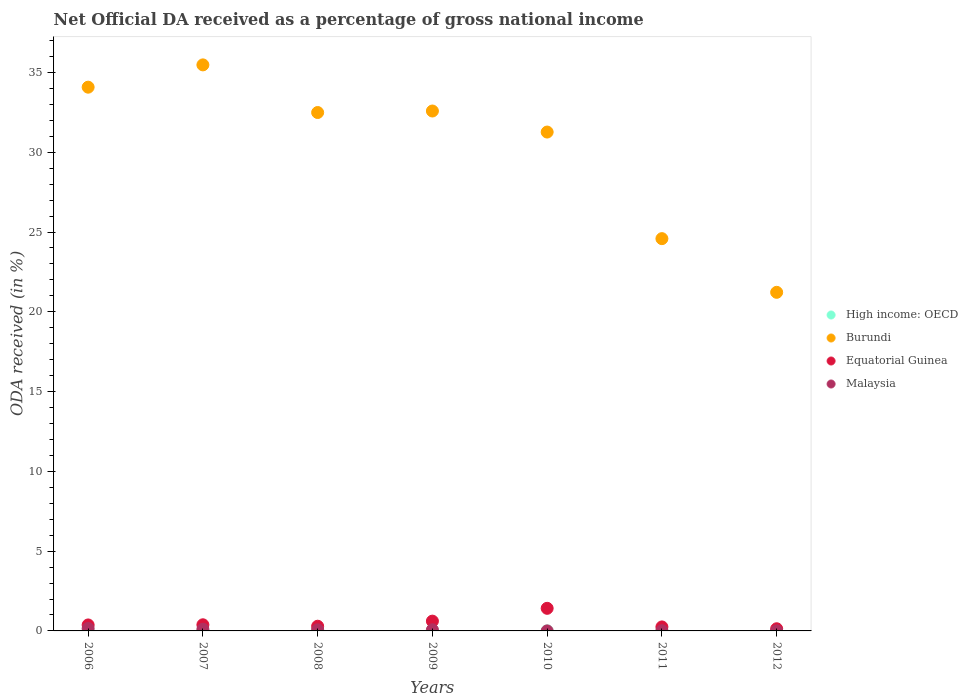What is the net official DA received in Malaysia in 2006?
Your answer should be compact. 0.15. Across all years, what is the maximum net official DA received in High income: OECD?
Provide a succinct answer. 0. Across all years, what is the minimum net official DA received in Malaysia?
Your answer should be very brief. 0. In which year was the net official DA received in Equatorial Guinea maximum?
Make the answer very short. 2010. What is the total net official DA received in Burundi in the graph?
Provide a short and direct response. 211.71. What is the difference between the net official DA received in Equatorial Guinea in 2008 and that in 2011?
Your answer should be very brief. 0.04. What is the difference between the net official DA received in High income: OECD in 2006 and the net official DA received in Malaysia in 2010?
Your response must be concise. -0. What is the average net official DA received in Equatorial Guinea per year?
Give a very brief answer. 0.5. In the year 2009, what is the difference between the net official DA received in Equatorial Guinea and net official DA received in Burundi?
Give a very brief answer. -31.97. What is the ratio of the net official DA received in Malaysia in 2009 to that in 2012?
Provide a short and direct response. 14.21. Is the difference between the net official DA received in Equatorial Guinea in 2007 and 2012 greater than the difference between the net official DA received in Burundi in 2007 and 2012?
Offer a very short reply. No. What is the difference between the highest and the second highest net official DA received in High income: OECD?
Make the answer very short. 0. What is the difference between the highest and the lowest net official DA received in High income: OECD?
Make the answer very short. 0. Is it the case that in every year, the sum of the net official DA received in Malaysia and net official DA received in Equatorial Guinea  is greater than the net official DA received in High income: OECD?
Give a very brief answer. Yes. How many years are there in the graph?
Offer a terse response. 7. What is the difference between two consecutive major ticks on the Y-axis?
Your answer should be very brief. 5. What is the title of the graph?
Provide a succinct answer. Net Official DA received as a percentage of gross national income. Does "Singapore" appear as one of the legend labels in the graph?
Keep it short and to the point. No. What is the label or title of the Y-axis?
Offer a very short reply. ODA received (in %). What is the ODA received (in %) of High income: OECD in 2006?
Offer a terse response. 0. What is the ODA received (in %) of Burundi in 2006?
Keep it short and to the point. 34.08. What is the ODA received (in %) in Equatorial Guinea in 2006?
Provide a short and direct response. 0.37. What is the ODA received (in %) of Malaysia in 2006?
Provide a short and direct response. 0.15. What is the ODA received (in %) in High income: OECD in 2007?
Your response must be concise. 0. What is the ODA received (in %) of Burundi in 2007?
Offer a very short reply. 35.48. What is the ODA received (in %) in Equatorial Guinea in 2007?
Provide a succinct answer. 0.38. What is the ODA received (in %) in Malaysia in 2007?
Your response must be concise. 0.11. What is the ODA received (in %) of High income: OECD in 2008?
Ensure brevity in your answer.  0. What is the ODA received (in %) of Burundi in 2008?
Give a very brief answer. 32.49. What is the ODA received (in %) of Equatorial Guinea in 2008?
Give a very brief answer. 0.29. What is the ODA received (in %) of Malaysia in 2008?
Keep it short and to the point. 0.07. What is the ODA received (in %) of High income: OECD in 2009?
Offer a very short reply. 0. What is the ODA received (in %) of Burundi in 2009?
Offer a terse response. 32.59. What is the ODA received (in %) of Equatorial Guinea in 2009?
Your answer should be very brief. 0.61. What is the ODA received (in %) of Malaysia in 2009?
Keep it short and to the point. 0.07. What is the ODA received (in %) in High income: OECD in 2010?
Provide a succinct answer. 0. What is the ODA received (in %) of Burundi in 2010?
Keep it short and to the point. 31.27. What is the ODA received (in %) in Equatorial Guinea in 2010?
Your response must be concise. 1.42. What is the ODA received (in %) of Malaysia in 2010?
Your response must be concise. 0. What is the ODA received (in %) in High income: OECD in 2011?
Offer a very short reply. 0. What is the ODA received (in %) of Burundi in 2011?
Offer a very short reply. 24.59. What is the ODA received (in %) in Equatorial Guinea in 2011?
Your response must be concise. 0.25. What is the ODA received (in %) in Malaysia in 2011?
Provide a short and direct response. 0.01. What is the ODA received (in %) of High income: OECD in 2012?
Keep it short and to the point. 0. What is the ODA received (in %) of Burundi in 2012?
Your answer should be compact. 21.22. What is the ODA received (in %) of Equatorial Guinea in 2012?
Provide a succinct answer. 0.14. What is the ODA received (in %) in Malaysia in 2012?
Provide a short and direct response. 0.01. Across all years, what is the maximum ODA received (in %) in High income: OECD?
Make the answer very short. 0. Across all years, what is the maximum ODA received (in %) in Burundi?
Give a very brief answer. 35.48. Across all years, what is the maximum ODA received (in %) of Equatorial Guinea?
Make the answer very short. 1.42. Across all years, what is the maximum ODA received (in %) of Malaysia?
Offer a terse response. 0.15. Across all years, what is the minimum ODA received (in %) of High income: OECD?
Provide a short and direct response. 0. Across all years, what is the minimum ODA received (in %) of Burundi?
Keep it short and to the point. 21.22. Across all years, what is the minimum ODA received (in %) of Equatorial Guinea?
Keep it short and to the point. 0.14. Across all years, what is the minimum ODA received (in %) of Malaysia?
Ensure brevity in your answer.  0. What is the total ODA received (in %) of High income: OECD in the graph?
Offer a very short reply. 0. What is the total ODA received (in %) of Burundi in the graph?
Your answer should be compact. 211.71. What is the total ODA received (in %) of Equatorial Guinea in the graph?
Give a very brief answer. 3.47. What is the total ODA received (in %) of Malaysia in the graph?
Provide a succinct answer. 0.41. What is the difference between the ODA received (in %) in High income: OECD in 2006 and that in 2007?
Ensure brevity in your answer.  0. What is the difference between the ODA received (in %) in Burundi in 2006 and that in 2007?
Your answer should be very brief. -1.4. What is the difference between the ODA received (in %) of Equatorial Guinea in 2006 and that in 2007?
Offer a terse response. -0.01. What is the difference between the ODA received (in %) of Malaysia in 2006 and that in 2007?
Offer a terse response. 0.05. What is the difference between the ODA received (in %) of High income: OECD in 2006 and that in 2008?
Your answer should be compact. 0. What is the difference between the ODA received (in %) in Burundi in 2006 and that in 2008?
Your answer should be very brief. 1.59. What is the difference between the ODA received (in %) of Equatorial Guinea in 2006 and that in 2008?
Offer a very short reply. 0.08. What is the difference between the ODA received (in %) in Malaysia in 2006 and that in 2008?
Offer a very short reply. 0.08. What is the difference between the ODA received (in %) of Burundi in 2006 and that in 2009?
Ensure brevity in your answer.  1.49. What is the difference between the ODA received (in %) of Equatorial Guinea in 2006 and that in 2009?
Ensure brevity in your answer.  -0.24. What is the difference between the ODA received (in %) in Malaysia in 2006 and that in 2009?
Give a very brief answer. 0.08. What is the difference between the ODA received (in %) of High income: OECD in 2006 and that in 2010?
Provide a succinct answer. -0. What is the difference between the ODA received (in %) in Burundi in 2006 and that in 2010?
Your answer should be compact. 2.81. What is the difference between the ODA received (in %) of Equatorial Guinea in 2006 and that in 2010?
Give a very brief answer. -1.04. What is the difference between the ODA received (in %) of Malaysia in 2006 and that in 2010?
Provide a succinct answer. 0.15. What is the difference between the ODA received (in %) of High income: OECD in 2006 and that in 2011?
Ensure brevity in your answer.  -0. What is the difference between the ODA received (in %) in Burundi in 2006 and that in 2011?
Give a very brief answer. 9.49. What is the difference between the ODA received (in %) of Equatorial Guinea in 2006 and that in 2011?
Offer a terse response. 0.12. What is the difference between the ODA received (in %) in Malaysia in 2006 and that in 2011?
Keep it short and to the point. 0.14. What is the difference between the ODA received (in %) in Burundi in 2006 and that in 2012?
Provide a short and direct response. 12.86. What is the difference between the ODA received (in %) of Equatorial Guinea in 2006 and that in 2012?
Provide a succinct answer. 0.24. What is the difference between the ODA received (in %) of Malaysia in 2006 and that in 2012?
Make the answer very short. 0.15. What is the difference between the ODA received (in %) in Burundi in 2007 and that in 2008?
Offer a very short reply. 2.99. What is the difference between the ODA received (in %) in Equatorial Guinea in 2007 and that in 2008?
Make the answer very short. 0.09. What is the difference between the ODA received (in %) of Malaysia in 2007 and that in 2008?
Ensure brevity in your answer.  0.04. What is the difference between the ODA received (in %) in High income: OECD in 2007 and that in 2009?
Your response must be concise. 0. What is the difference between the ODA received (in %) of Burundi in 2007 and that in 2009?
Your response must be concise. 2.89. What is the difference between the ODA received (in %) in Equatorial Guinea in 2007 and that in 2009?
Make the answer very short. -0.23. What is the difference between the ODA received (in %) of Malaysia in 2007 and that in 2009?
Offer a very short reply. 0.03. What is the difference between the ODA received (in %) of High income: OECD in 2007 and that in 2010?
Offer a terse response. -0. What is the difference between the ODA received (in %) in Burundi in 2007 and that in 2010?
Your response must be concise. 4.21. What is the difference between the ODA received (in %) of Equatorial Guinea in 2007 and that in 2010?
Keep it short and to the point. -1.03. What is the difference between the ODA received (in %) of Malaysia in 2007 and that in 2010?
Provide a short and direct response. 0.1. What is the difference between the ODA received (in %) in High income: OECD in 2007 and that in 2011?
Ensure brevity in your answer.  -0. What is the difference between the ODA received (in %) of Burundi in 2007 and that in 2011?
Offer a very short reply. 10.89. What is the difference between the ODA received (in %) in Equatorial Guinea in 2007 and that in 2011?
Offer a very short reply. 0.13. What is the difference between the ODA received (in %) in Malaysia in 2007 and that in 2011?
Your answer should be very brief. 0.09. What is the difference between the ODA received (in %) of High income: OECD in 2007 and that in 2012?
Your response must be concise. -0. What is the difference between the ODA received (in %) in Burundi in 2007 and that in 2012?
Your answer should be very brief. 14.26. What is the difference between the ODA received (in %) of Equatorial Guinea in 2007 and that in 2012?
Your response must be concise. 0.25. What is the difference between the ODA received (in %) of Malaysia in 2007 and that in 2012?
Provide a succinct answer. 0.1. What is the difference between the ODA received (in %) of High income: OECD in 2008 and that in 2009?
Your answer should be compact. 0. What is the difference between the ODA received (in %) in Burundi in 2008 and that in 2009?
Offer a very short reply. -0.09. What is the difference between the ODA received (in %) in Equatorial Guinea in 2008 and that in 2009?
Give a very brief answer. -0.32. What is the difference between the ODA received (in %) of Malaysia in 2008 and that in 2009?
Provide a short and direct response. -0. What is the difference between the ODA received (in %) of High income: OECD in 2008 and that in 2010?
Your answer should be very brief. -0. What is the difference between the ODA received (in %) in Burundi in 2008 and that in 2010?
Keep it short and to the point. 1.22. What is the difference between the ODA received (in %) of Equatorial Guinea in 2008 and that in 2010?
Provide a short and direct response. -1.12. What is the difference between the ODA received (in %) in Malaysia in 2008 and that in 2010?
Provide a short and direct response. 0.07. What is the difference between the ODA received (in %) of High income: OECD in 2008 and that in 2011?
Offer a very short reply. -0. What is the difference between the ODA received (in %) in Burundi in 2008 and that in 2011?
Make the answer very short. 7.91. What is the difference between the ODA received (in %) of Equatorial Guinea in 2008 and that in 2011?
Offer a very short reply. 0.04. What is the difference between the ODA received (in %) in Malaysia in 2008 and that in 2011?
Make the answer very short. 0.06. What is the difference between the ODA received (in %) in Burundi in 2008 and that in 2012?
Provide a short and direct response. 11.27. What is the difference between the ODA received (in %) in Equatorial Guinea in 2008 and that in 2012?
Ensure brevity in your answer.  0.16. What is the difference between the ODA received (in %) in Malaysia in 2008 and that in 2012?
Offer a very short reply. 0.06. What is the difference between the ODA received (in %) of High income: OECD in 2009 and that in 2010?
Ensure brevity in your answer.  -0. What is the difference between the ODA received (in %) of Burundi in 2009 and that in 2010?
Make the answer very short. 1.32. What is the difference between the ODA received (in %) in Equatorial Guinea in 2009 and that in 2010?
Make the answer very short. -0.8. What is the difference between the ODA received (in %) in Malaysia in 2009 and that in 2010?
Your answer should be very brief. 0.07. What is the difference between the ODA received (in %) of High income: OECD in 2009 and that in 2011?
Your response must be concise. -0. What is the difference between the ODA received (in %) of Burundi in 2009 and that in 2011?
Give a very brief answer. 8. What is the difference between the ODA received (in %) of Equatorial Guinea in 2009 and that in 2011?
Your answer should be compact. 0.36. What is the difference between the ODA received (in %) of Malaysia in 2009 and that in 2011?
Make the answer very short. 0.06. What is the difference between the ODA received (in %) in High income: OECD in 2009 and that in 2012?
Provide a succinct answer. -0. What is the difference between the ODA received (in %) of Burundi in 2009 and that in 2012?
Your answer should be very brief. 11.36. What is the difference between the ODA received (in %) in Equatorial Guinea in 2009 and that in 2012?
Your answer should be compact. 0.48. What is the difference between the ODA received (in %) in Malaysia in 2009 and that in 2012?
Your answer should be very brief. 0.07. What is the difference between the ODA received (in %) of High income: OECD in 2010 and that in 2011?
Provide a short and direct response. 0. What is the difference between the ODA received (in %) of Burundi in 2010 and that in 2011?
Offer a terse response. 6.68. What is the difference between the ODA received (in %) in Equatorial Guinea in 2010 and that in 2011?
Offer a terse response. 1.17. What is the difference between the ODA received (in %) of Malaysia in 2010 and that in 2011?
Offer a terse response. -0.01. What is the difference between the ODA received (in %) in High income: OECD in 2010 and that in 2012?
Your response must be concise. 0. What is the difference between the ODA received (in %) of Burundi in 2010 and that in 2012?
Ensure brevity in your answer.  10.04. What is the difference between the ODA received (in %) in Equatorial Guinea in 2010 and that in 2012?
Offer a terse response. 1.28. What is the difference between the ODA received (in %) of Malaysia in 2010 and that in 2012?
Your answer should be very brief. -0. What is the difference between the ODA received (in %) of Burundi in 2011 and that in 2012?
Your answer should be very brief. 3.36. What is the difference between the ODA received (in %) in Equatorial Guinea in 2011 and that in 2012?
Keep it short and to the point. 0.11. What is the difference between the ODA received (in %) in Malaysia in 2011 and that in 2012?
Provide a short and direct response. 0.01. What is the difference between the ODA received (in %) of High income: OECD in 2006 and the ODA received (in %) of Burundi in 2007?
Keep it short and to the point. -35.48. What is the difference between the ODA received (in %) of High income: OECD in 2006 and the ODA received (in %) of Equatorial Guinea in 2007?
Ensure brevity in your answer.  -0.38. What is the difference between the ODA received (in %) of High income: OECD in 2006 and the ODA received (in %) of Malaysia in 2007?
Your answer should be compact. -0.11. What is the difference between the ODA received (in %) in Burundi in 2006 and the ODA received (in %) in Equatorial Guinea in 2007?
Offer a terse response. 33.69. What is the difference between the ODA received (in %) of Burundi in 2006 and the ODA received (in %) of Malaysia in 2007?
Your answer should be very brief. 33.97. What is the difference between the ODA received (in %) in Equatorial Guinea in 2006 and the ODA received (in %) in Malaysia in 2007?
Your response must be concise. 0.27. What is the difference between the ODA received (in %) of High income: OECD in 2006 and the ODA received (in %) of Burundi in 2008?
Offer a very short reply. -32.49. What is the difference between the ODA received (in %) in High income: OECD in 2006 and the ODA received (in %) in Equatorial Guinea in 2008?
Ensure brevity in your answer.  -0.29. What is the difference between the ODA received (in %) of High income: OECD in 2006 and the ODA received (in %) of Malaysia in 2008?
Give a very brief answer. -0.07. What is the difference between the ODA received (in %) of Burundi in 2006 and the ODA received (in %) of Equatorial Guinea in 2008?
Ensure brevity in your answer.  33.79. What is the difference between the ODA received (in %) in Burundi in 2006 and the ODA received (in %) in Malaysia in 2008?
Ensure brevity in your answer.  34.01. What is the difference between the ODA received (in %) of Equatorial Guinea in 2006 and the ODA received (in %) of Malaysia in 2008?
Provide a short and direct response. 0.31. What is the difference between the ODA received (in %) of High income: OECD in 2006 and the ODA received (in %) of Burundi in 2009?
Your response must be concise. -32.58. What is the difference between the ODA received (in %) of High income: OECD in 2006 and the ODA received (in %) of Equatorial Guinea in 2009?
Your answer should be very brief. -0.61. What is the difference between the ODA received (in %) of High income: OECD in 2006 and the ODA received (in %) of Malaysia in 2009?
Ensure brevity in your answer.  -0.07. What is the difference between the ODA received (in %) of Burundi in 2006 and the ODA received (in %) of Equatorial Guinea in 2009?
Your response must be concise. 33.47. What is the difference between the ODA received (in %) in Burundi in 2006 and the ODA received (in %) in Malaysia in 2009?
Provide a succinct answer. 34.01. What is the difference between the ODA received (in %) in Equatorial Guinea in 2006 and the ODA received (in %) in Malaysia in 2009?
Give a very brief answer. 0.3. What is the difference between the ODA received (in %) in High income: OECD in 2006 and the ODA received (in %) in Burundi in 2010?
Your response must be concise. -31.27. What is the difference between the ODA received (in %) in High income: OECD in 2006 and the ODA received (in %) in Equatorial Guinea in 2010?
Make the answer very short. -1.42. What is the difference between the ODA received (in %) in High income: OECD in 2006 and the ODA received (in %) in Malaysia in 2010?
Your answer should be compact. -0. What is the difference between the ODA received (in %) in Burundi in 2006 and the ODA received (in %) in Equatorial Guinea in 2010?
Offer a terse response. 32.66. What is the difference between the ODA received (in %) in Burundi in 2006 and the ODA received (in %) in Malaysia in 2010?
Your answer should be very brief. 34.08. What is the difference between the ODA received (in %) of Equatorial Guinea in 2006 and the ODA received (in %) of Malaysia in 2010?
Your response must be concise. 0.37. What is the difference between the ODA received (in %) of High income: OECD in 2006 and the ODA received (in %) of Burundi in 2011?
Provide a succinct answer. -24.59. What is the difference between the ODA received (in %) of High income: OECD in 2006 and the ODA received (in %) of Equatorial Guinea in 2011?
Ensure brevity in your answer.  -0.25. What is the difference between the ODA received (in %) in High income: OECD in 2006 and the ODA received (in %) in Malaysia in 2011?
Ensure brevity in your answer.  -0.01. What is the difference between the ODA received (in %) of Burundi in 2006 and the ODA received (in %) of Equatorial Guinea in 2011?
Offer a terse response. 33.83. What is the difference between the ODA received (in %) in Burundi in 2006 and the ODA received (in %) in Malaysia in 2011?
Your response must be concise. 34.07. What is the difference between the ODA received (in %) of Equatorial Guinea in 2006 and the ODA received (in %) of Malaysia in 2011?
Your response must be concise. 0.36. What is the difference between the ODA received (in %) of High income: OECD in 2006 and the ODA received (in %) of Burundi in 2012?
Keep it short and to the point. -21.22. What is the difference between the ODA received (in %) in High income: OECD in 2006 and the ODA received (in %) in Equatorial Guinea in 2012?
Ensure brevity in your answer.  -0.14. What is the difference between the ODA received (in %) of High income: OECD in 2006 and the ODA received (in %) of Malaysia in 2012?
Keep it short and to the point. -0. What is the difference between the ODA received (in %) of Burundi in 2006 and the ODA received (in %) of Equatorial Guinea in 2012?
Your response must be concise. 33.94. What is the difference between the ODA received (in %) of Burundi in 2006 and the ODA received (in %) of Malaysia in 2012?
Keep it short and to the point. 34.07. What is the difference between the ODA received (in %) in Equatorial Guinea in 2006 and the ODA received (in %) in Malaysia in 2012?
Offer a very short reply. 0.37. What is the difference between the ODA received (in %) in High income: OECD in 2007 and the ODA received (in %) in Burundi in 2008?
Ensure brevity in your answer.  -32.49. What is the difference between the ODA received (in %) of High income: OECD in 2007 and the ODA received (in %) of Equatorial Guinea in 2008?
Provide a short and direct response. -0.29. What is the difference between the ODA received (in %) of High income: OECD in 2007 and the ODA received (in %) of Malaysia in 2008?
Provide a succinct answer. -0.07. What is the difference between the ODA received (in %) of Burundi in 2007 and the ODA received (in %) of Equatorial Guinea in 2008?
Provide a short and direct response. 35.18. What is the difference between the ODA received (in %) in Burundi in 2007 and the ODA received (in %) in Malaysia in 2008?
Offer a terse response. 35.41. What is the difference between the ODA received (in %) of Equatorial Guinea in 2007 and the ODA received (in %) of Malaysia in 2008?
Your answer should be very brief. 0.32. What is the difference between the ODA received (in %) in High income: OECD in 2007 and the ODA received (in %) in Burundi in 2009?
Provide a succinct answer. -32.58. What is the difference between the ODA received (in %) of High income: OECD in 2007 and the ODA received (in %) of Equatorial Guinea in 2009?
Offer a terse response. -0.61. What is the difference between the ODA received (in %) in High income: OECD in 2007 and the ODA received (in %) in Malaysia in 2009?
Give a very brief answer. -0.07. What is the difference between the ODA received (in %) of Burundi in 2007 and the ODA received (in %) of Equatorial Guinea in 2009?
Ensure brevity in your answer.  34.86. What is the difference between the ODA received (in %) in Burundi in 2007 and the ODA received (in %) in Malaysia in 2009?
Offer a very short reply. 35.4. What is the difference between the ODA received (in %) of Equatorial Guinea in 2007 and the ODA received (in %) of Malaysia in 2009?
Your answer should be compact. 0.31. What is the difference between the ODA received (in %) of High income: OECD in 2007 and the ODA received (in %) of Burundi in 2010?
Make the answer very short. -31.27. What is the difference between the ODA received (in %) of High income: OECD in 2007 and the ODA received (in %) of Equatorial Guinea in 2010?
Keep it short and to the point. -1.42. What is the difference between the ODA received (in %) in High income: OECD in 2007 and the ODA received (in %) in Malaysia in 2010?
Offer a very short reply. -0. What is the difference between the ODA received (in %) in Burundi in 2007 and the ODA received (in %) in Equatorial Guinea in 2010?
Provide a short and direct response. 34.06. What is the difference between the ODA received (in %) in Burundi in 2007 and the ODA received (in %) in Malaysia in 2010?
Your response must be concise. 35.48. What is the difference between the ODA received (in %) in Equatorial Guinea in 2007 and the ODA received (in %) in Malaysia in 2010?
Offer a very short reply. 0.38. What is the difference between the ODA received (in %) of High income: OECD in 2007 and the ODA received (in %) of Burundi in 2011?
Provide a short and direct response. -24.59. What is the difference between the ODA received (in %) in High income: OECD in 2007 and the ODA received (in %) in Equatorial Guinea in 2011?
Keep it short and to the point. -0.25. What is the difference between the ODA received (in %) of High income: OECD in 2007 and the ODA received (in %) of Malaysia in 2011?
Provide a succinct answer. -0.01. What is the difference between the ODA received (in %) in Burundi in 2007 and the ODA received (in %) in Equatorial Guinea in 2011?
Offer a very short reply. 35.23. What is the difference between the ODA received (in %) in Burundi in 2007 and the ODA received (in %) in Malaysia in 2011?
Offer a very short reply. 35.47. What is the difference between the ODA received (in %) in Equatorial Guinea in 2007 and the ODA received (in %) in Malaysia in 2011?
Provide a short and direct response. 0.37. What is the difference between the ODA received (in %) of High income: OECD in 2007 and the ODA received (in %) of Burundi in 2012?
Ensure brevity in your answer.  -21.22. What is the difference between the ODA received (in %) of High income: OECD in 2007 and the ODA received (in %) of Equatorial Guinea in 2012?
Offer a very short reply. -0.14. What is the difference between the ODA received (in %) of High income: OECD in 2007 and the ODA received (in %) of Malaysia in 2012?
Make the answer very short. -0. What is the difference between the ODA received (in %) of Burundi in 2007 and the ODA received (in %) of Equatorial Guinea in 2012?
Your answer should be very brief. 35.34. What is the difference between the ODA received (in %) of Burundi in 2007 and the ODA received (in %) of Malaysia in 2012?
Your answer should be compact. 35.47. What is the difference between the ODA received (in %) of Equatorial Guinea in 2007 and the ODA received (in %) of Malaysia in 2012?
Your answer should be compact. 0.38. What is the difference between the ODA received (in %) in High income: OECD in 2008 and the ODA received (in %) in Burundi in 2009?
Your response must be concise. -32.58. What is the difference between the ODA received (in %) in High income: OECD in 2008 and the ODA received (in %) in Equatorial Guinea in 2009?
Offer a very short reply. -0.61. What is the difference between the ODA received (in %) in High income: OECD in 2008 and the ODA received (in %) in Malaysia in 2009?
Give a very brief answer. -0.07. What is the difference between the ODA received (in %) of Burundi in 2008 and the ODA received (in %) of Equatorial Guinea in 2009?
Keep it short and to the point. 31.88. What is the difference between the ODA received (in %) in Burundi in 2008 and the ODA received (in %) in Malaysia in 2009?
Provide a short and direct response. 32.42. What is the difference between the ODA received (in %) in Equatorial Guinea in 2008 and the ODA received (in %) in Malaysia in 2009?
Give a very brief answer. 0.22. What is the difference between the ODA received (in %) in High income: OECD in 2008 and the ODA received (in %) in Burundi in 2010?
Provide a succinct answer. -31.27. What is the difference between the ODA received (in %) in High income: OECD in 2008 and the ODA received (in %) in Equatorial Guinea in 2010?
Give a very brief answer. -1.42. What is the difference between the ODA received (in %) in High income: OECD in 2008 and the ODA received (in %) in Malaysia in 2010?
Your response must be concise. -0. What is the difference between the ODA received (in %) in Burundi in 2008 and the ODA received (in %) in Equatorial Guinea in 2010?
Offer a terse response. 31.07. What is the difference between the ODA received (in %) of Burundi in 2008 and the ODA received (in %) of Malaysia in 2010?
Offer a terse response. 32.49. What is the difference between the ODA received (in %) of Equatorial Guinea in 2008 and the ODA received (in %) of Malaysia in 2010?
Your answer should be compact. 0.29. What is the difference between the ODA received (in %) in High income: OECD in 2008 and the ODA received (in %) in Burundi in 2011?
Your response must be concise. -24.59. What is the difference between the ODA received (in %) of High income: OECD in 2008 and the ODA received (in %) of Equatorial Guinea in 2011?
Provide a short and direct response. -0.25. What is the difference between the ODA received (in %) in High income: OECD in 2008 and the ODA received (in %) in Malaysia in 2011?
Offer a very short reply. -0.01. What is the difference between the ODA received (in %) in Burundi in 2008 and the ODA received (in %) in Equatorial Guinea in 2011?
Keep it short and to the point. 32.24. What is the difference between the ODA received (in %) of Burundi in 2008 and the ODA received (in %) of Malaysia in 2011?
Ensure brevity in your answer.  32.48. What is the difference between the ODA received (in %) in Equatorial Guinea in 2008 and the ODA received (in %) in Malaysia in 2011?
Offer a terse response. 0.28. What is the difference between the ODA received (in %) in High income: OECD in 2008 and the ODA received (in %) in Burundi in 2012?
Offer a terse response. -21.22. What is the difference between the ODA received (in %) in High income: OECD in 2008 and the ODA received (in %) in Equatorial Guinea in 2012?
Provide a short and direct response. -0.14. What is the difference between the ODA received (in %) in High income: OECD in 2008 and the ODA received (in %) in Malaysia in 2012?
Offer a terse response. -0. What is the difference between the ODA received (in %) in Burundi in 2008 and the ODA received (in %) in Equatorial Guinea in 2012?
Provide a succinct answer. 32.36. What is the difference between the ODA received (in %) in Burundi in 2008 and the ODA received (in %) in Malaysia in 2012?
Give a very brief answer. 32.49. What is the difference between the ODA received (in %) in Equatorial Guinea in 2008 and the ODA received (in %) in Malaysia in 2012?
Make the answer very short. 0.29. What is the difference between the ODA received (in %) in High income: OECD in 2009 and the ODA received (in %) in Burundi in 2010?
Ensure brevity in your answer.  -31.27. What is the difference between the ODA received (in %) of High income: OECD in 2009 and the ODA received (in %) of Equatorial Guinea in 2010?
Offer a very short reply. -1.42. What is the difference between the ODA received (in %) in High income: OECD in 2009 and the ODA received (in %) in Malaysia in 2010?
Your answer should be compact. -0. What is the difference between the ODA received (in %) in Burundi in 2009 and the ODA received (in %) in Equatorial Guinea in 2010?
Ensure brevity in your answer.  31.17. What is the difference between the ODA received (in %) in Burundi in 2009 and the ODA received (in %) in Malaysia in 2010?
Give a very brief answer. 32.58. What is the difference between the ODA received (in %) of Equatorial Guinea in 2009 and the ODA received (in %) of Malaysia in 2010?
Keep it short and to the point. 0.61. What is the difference between the ODA received (in %) in High income: OECD in 2009 and the ODA received (in %) in Burundi in 2011?
Offer a terse response. -24.59. What is the difference between the ODA received (in %) of High income: OECD in 2009 and the ODA received (in %) of Equatorial Guinea in 2011?
Keep it short and to the point. -0.25. What is the difference between the ODA received (in %) of High income: OECD in 2009 and the ODA received (in %) of Malaysia in 2011?
Make the answer very short. -0.01. What is the difference between the ODA received (in %) in Burundi in 2009 and the ODA received (in %) in Equatorial Guinea in 2011?
Make the answer very short. 32.33. What is the difference between the ODA received (in %) of Burundi in 2009 and the ODA received (in %) of Malaysia in 2011?
Make the answer very short. 32.57. What is the difference between the ODA received (in %) in Equatorial Guinea in 2009 and the ODA received (in %) in Malaysia in 2011?
Your answer should be very brief. 0.6. What is the difference between the ODA received (in %) in High income: OECD in 2009 and the ODA received (in %) in Burundi in 2012?
Make the answer very short. -21.22. What is the difference between the ODA received (in %) in High income: OECD in 2009 and the ODA received (in %) in Equatorial Guinea in 2012?
Provide a short and direct response. -0.14. What is the difference between the ODA received (in %) in High income: OECD in 2009 and the ODA received (in %) in Malaysia in 2012?
Provide a succinct answer. -0. What is the difference between the ODA received (in %) in Burundi in 2009 and the ODA received (in %) in Equatorial Guinea in 2012?
Make the answer very short. 32.45. What is the difference between the ODA received (in %) of Burundi in 2009 and the ODA received (in %) of Malaysia in 2012?
Your response must be concise. 32.58. What is the difference between the ODA received (in %) of Equatorial Guinea in 2009 and the ODA received (in %) of Malaysia in 2012?
Your answer should be very brief. 0.61. What is the difference between the ODA received (in %) in High income: OECD in 2010 and the ODA received (in %) in Burundi in 2011?
Your answer should be very brief. -24.59. What is the difference between the ODA received (in %) in High income: OECD in 2010 and the ODA received (in %) in Equatorial Guinea in 2011?
Offer a very short reply. -0.25. What is the difference between the ODA received (in %) in High income: OECD in 2010 and the ODA received (in %) in Malaysia in 2011?
Your answer should be compact. -0.01. What is the difference between the ODA received (in %) in Burundi in 2010 and the ODA received (in %) in Equatorial Guinea in 2011?
Make the answer very short. 31.02. What is the difference between the ODA received (in %) in Burundi in 2010 and the ODA received (in %) in Malaysia in 2011?
Offer a terse response. 31.26. What is the difference between the ODA received (in %) of Equatorial Guinea in 2010 and the ODA received (in %) of Malaysia in 2011?
Offer a very short reply. 1.41. What is the difference between the ODA received (in %) in High income: OECD in 2010 and the ODA received (in %) in Burundi in 2012?
Provide a short and direct response. -21.22. What is the difference between the ODA received (in %) of High income: OECD in 2010 and the ODA received (in %) of Equatorial Guinea in 2012?
Make the answer very short. -0.14. What is the difference between the ODA received (in %) of High income: OECD in 2010 and the ODA received (in %) of Malaysia in 2012?
Make the answer very short. -0. What is the difference between the ODA received (in %) in Burundi in 2010 and the ODA received (in %) in Equatorial Guinea in 2012?
Give a very brief answer. 31.13. What is the difference between the ODA received (in %) in Burundi in 2010 and the ODA received (in %) in Malaysia in 2012?
Your response must be concise. 31.26. What is the difference between the ODA received (in %) in Equatorial Guinea in 2010 and the ODA received (in %) in Malaysia in 2012?
Provide a succinct answer. 1.41. What is the difference between the ODA received (in %) of High income: OECD in 2011 and the ODA received (in %) of Burundi in 2012?
Offer a terse response. -21.22. What is the difference between the ODA received (in %) in High income: OECD in 2011 and the ODA received (in %) in Equatorial Guinea in 2012?
Your answer should be compact. -0.14. What is the difference between the ODA received (in %) in High income: OECD in 2011 and the ODA received (in %) in Malaysia in 2012?
Provide a short and direct response. -0. What is the difference between the ODA received (in %) in Burundi in 2011 and the ODA received (in %) in Equatorial Guinea in 2012?
Ensure brevity in your answer.  24.45. What is the difference between the ODA received (in %) of Burundi in 2011 and the ODA received (in %) of Malaysia in 2012?
Your response must be concise. 24.58. What is the difference between the ODA received (in %) of Equatorial Guinea in 2011 and the ODA received (in %) of Malaysia in 2012?
Your answer should be compact. 0.25. What is the average ODA received (in %) of High income: OECD per year?
Your answer should be very brief. 0. What is the average ODA received (in %) of Burundi per year?
Make the answer very short. 30.24. What is the average ODA received (in %) in Equatorial Guinea per year?
Your response must be concise. 0.5. What is the average ODA received (in %) in Malaysia per year?
Your answer should be very brief. 0.06. In the year 2006, what is the difference between the ODA received (in %) in High income: OECD and ODA received (in %) in Burundi?
Offer a terse response. -34.08. In the year 2006, what is the difference between the ODA received (in %) in High income: OECD and ODA received (in %) in Equatorial Guinea?
Make the answer very short. -0.37. In the year 2006, what is the difference between the ODA received (in %) of High income: OECD and ODA received (in %) of Malaysia?
Provide a succinct answer. -0.15. In the year 2006, what is the difference between the ODA received (in %) in Burundi and ODA received (in %) in Equatorial Guinea?
Make the answer very short. 33.7. In the year 2006, what is the difference between the ODA received (in %) in Burundi and ODA received (in %) in Malaysia?
Provide a succinct answer. 33.93. In the year 2006, what is the difference between the ODA received (in %) in Equatorial Guinea and ODA received (in %) in Malaysia?
Ensure brevity in your answer.  0.22. In the year 2007, what is the difference between the ODA received (in %) of High income: OECD and ODA received (in %) of Burundi?
Provide a short and direct response. -35.48. In the year 2007, what is the difference between the ODA received (in %) of High income: OECD and ODA received (in %) of Equatorial Guinea?
Your answer should be very brief. -0.38. In the year 2007, what is the difference between the ODA received (in %) of High income: OECD and ODA received (in %) of Malaysia?
Keep it short and to the point. -0.11. In the year 2007, what is the difference between the ODA received (in %) in Burundi and ODA received (in %) in Equatorial Guinea?
Offer a terse response. 35.09. In the year 2007, what is the difference between the ODA received (in %) of Burundi and ODA received (in %) of Malaysia?
Make the answer very short. 35.37. In the year 2007, what is the difference between the ODA received (in %) of Equatorial Guinea and ODA received (in %) of Malaysia?
Provide a succinct answer. 0.28. In the year 2008, what is the difference between the ODA received (in %) in High income: OECD and ODA received (in %) in Burundi?
Ensure brevity in your answer.  -32.49. In the year 2008, what is the difference between the ODA received (in %) in High income: OECD and ODA received (in %) in Equatorial Guinea?
Offer a very short reply. -0.29. In the year 2008, what is the difference between the ODA received (in %) in High income: OECD and ODA received (in %) in Malaysia?
Ensure brevity in your answer.  -0.07. In the year 2008, what is the difference between the ODA received (in %) of Burundi and ODA received (in %) of Equatorial Guinea?
Provide a short and direct response. 32.2. In the year 2008, what is the difference between the ODA received (in %) in Burundi and ODA received (in %) in Malaysia?
Your response must be concise. 32.42. In the year 2008, what is the difference between the ODA received (in %) in Equatorial Guinea and ODA received (in %) in Malaysia?
Offer a very short reply. 0.23. In the year 2009, what is the difference between the ODA received (in %) in High income: OECD and ODA received (in %) in Burundi?
Your answer should be very brief. -32.58. In the year 2009, what is the difference between the ODA received (in %) of High income: OECD and ODA received (in %) of Equatorial Guinea?
Keep it short and to the point. -0.61. In the year 2009, what is the difference between the ODA received (in %) of High income: OECD and ODA received (in %) of Malaysia?
Make the answer very short. -0.07. In the year 2009, what is the difference between the ODA received (in %) of Burundi and ODA received (in %) of Equatorial Guinea?
Make the answer very short. 31.97. In the year 2009, what is the difference between the ODA received (in %) in Burundi and ODA received (in %) in Malaysia?
Provide a succinct answer. 32.51. In the year 2009, what is the difference between the ODA received (in %) in Equatorial Guinea and ODA received (in %) in Malaysia?
Keep it short and to the point. 0.54. In the year 2010, what is the difference between the ODA received (in %) in High income: OECD and ODA received (in %) in Burundi?
Your answer should be very brief. -31.27. In the year 2010, what is the difference between the ODA received (in %) of High income: OECD and ODA received (in %) of Equatorial Guinea?
Ensure brevity in your answer.  -1.42. In the year 2010, what is the difference between the ODA received (in %) in High income: OECD and ODA received (in %) in Malaysia?
Your answer should be very brief. -0. In the year 2010, what is the difference between the ODA received (in %) in Burundi and ODA received (in %) in Equatorial Guinea?
Offer a terse response. 29.85. In the year 2010, what is the difference between the ODA received (in %) of Burundi and ODA received (in %) of Malaysia?
Your answer should be very brief. 31.27. In the year 2010, what is the difference between the ODA received (in %) of Equatorial Guinea and ODA received (in %) of Malaysia?
Offer a terse response. 1.42. In the year 2011, what is the difference between the ODA received (in %) in High income: OECD and ODA received (in %) in Burundi?
Provide a short and direct response. -24.59. In the year 2011, what is the difference between the ODA received (in %) of High income: OECD and ODA received (in %) of Equatorial Guinea?
Provide a short and direct response. -0.25. In the year 2011, what is the difference between the ODA received (in %) in High income: OECD and ODA received (in %) in Malaysia?
Provide a succinct answer. -0.01. In the year 2011, what is the difference between the ODA received (in %) in Burundi and ODA received (in %) in Equatorial Guinea?
Ensure brevity in your answer.  24.34. In the year 2011, what is the difference between the ODA received (in %) in Burundi and ODA received (in %) in Malaysia?
Your answer should be compact. 24.57. In the year 2011, what is the difference between the ODA received (in %) of Equatorial Guinea and ODA received (in %) of Malaysia?
Your answer should be very brief. 0.24. In the year 2012, what is the difference between the ODA received (in %) in High income: OECD and ODA received (in %) in Burundi?
Provide a short and direct response. -21.22. In the year 2012, what is the difference between the ODA received (in %) in High income: OECD and ODA received (in %) in Equatorial Guinea?
Offer a terse response. -0.14. In the year 2012, what is the difference between the ODA received (in %) in High income: OECD and ODA received (in %) in Malaysia?
Ensure brevity in your answer.  -0. In the year 2012, what is the difference between the ODA received (in %) of Burundi and ODA received (in %) of Equatorial Guinea?
Give a very brief answer. 21.09. In the year 2012, what is the difference between the ODA received (in %) in Burundi and ODA received (in %) in Malaysia?
Provide a short and direct response. 21.22. In the year 2012, what is the difference between the ODA received (in %) of Equatorial Guinea and ODA received (in %) of Malaysia?
Ensure brevity in your answer.  0.13. What is the ratio of the ODA received (in %) in High income: OECD in 2006 to that in 2007?
Make the answer very short. 1.05. What is the ratio of the ODA received (in %) of Burundi in 2006 to that in 2007?
Make the answer very short. 0.96. What is the ratio of the ODA received (in %) in Equatorial Guinea in 2006 to that in 2007?
Make the answer very short. 0.97. What is the ratio of the ODA received (in %) of Malaysia in 2006 to that in 2007?
Keep it short and to the point. 1.43. What is the ratio of the ODA received (in %) of High income: OECD in 2006 to that in 2008?
Your answer should be compact. 1.07. What is the ratio of the ODA received (in %) in Burundi in 2006 to that in 2008?
Offer a very short reply. 1.05. What is the ratio of the ODA received (in %) of Equatorial Guinea in 2006 to that in 2008?
Your answer should be very brief. 1.27. What is the ratio of the ODA received (in %) of Malaysia in 2006 to that in 2008?
Keep it short and to the point. 2.19. What is the ratio of the ODA received (in %) of High income: OECD in 2006 to that in 2009?
Your response must be concise. 1.39. What is the ratio of the ODA received (in %) of Burundi in 2006 to that in 2009?
Your response must be concise. 1.05. What is the ratio of the ODA received (in %) of Equatorial Guinea in 2006 to that in 2009?
Your response must be concise. 0.61. What is the ratio of the ODA received (in %) in Malaysia in 2006 to that in 2009?
Provide a short and direct response. 2.1. What is the ratio of the ODA received (in %) in High income: OECD in 2006 to that in 2010?
Offer a terse response. 0.58. What is the ratio of the ODA received (in %) of Burundi in 2006 to that in 2010?
Make the answer very short. 1.09. What is the ratio of the ODA received (in %) in Equatorial Guinea in 2006 to that in 2010?
Offer a very short reply. 0.26. What is the ratio of the ODA received (in %) in Malaysia in 2006 to that in 2010?
Your response must be concise. 181.11. What is the ratio of the ODA received (in %) in High income: OECD in 2006 to that in 2011?
Your answer should be very brief. 0.75. What is the ratio of the ODA received (in %) in Burundi in 2006 to that in 2011?
Offer a very short reply. 1.39. What is the ratio of the ODA received (in %) in Equatorial Guinea in 2006 to that in 2011?
Offer a terse response. 1.5. What is the ratio of the ODA received (in %) of Malaysia in 2006 to that in 2011?
Ensure brevity in your answer.  13.69. What is the ratio of the ODA received (in %) in High income: OECD in 2006 to that in 2012?
Offer a very short reply. 0.99. What is the ratio of the ODA received (in %) in Burundi in 2006 to that in 2012?
Your response must be concise. 1.61. What is the ratio of the ODA received (in %) in Equatorial Guinea in 2006 to that in 2012?
Keep it short and to the point. 2.76. What is the ratio of the ODA received (in %) in Malaysia in 2006 to that in 2012?
Offer a terse response. 29.77. What is the ratio of the ODA received (in %) in High income: OECD in 2007 to that in 2008?
Ensure brevity in your answer.  1.02. What is the ratio of the ODA received (in %) in Burundi in 2007 to that in 2008?
Your answer should be compact. 1.09. What is the ratio of the ODA received (in %) in Equatorial Guinea in 2007 to that in 2008?
Ensure brevity in your answer.  1.31. What is the ratio of the ODA received (in %) in Malaysia in 2007 to that in 2008?
Your answer should be compact. 1.53. What is the ratio of the ODA received (in %) in High income: OECD in 2007 to that in 2009?
Provide a succinct answer. 1.32. What is the ratio of the ODA received (in %) of Burundi in 2007 to that in 2009?
Provide a succinct answer. 1.09. What is the ratio of the ODA received (in %) in Equatorial Guinea in 2007 to that in 2009?
Keep it short and to the point. 0.63. What is the ratio of the ODA received (in %) of Malaysia in 2007 to that in 2009?
Give a very brief answer. 1.46. What is the ratio of the ODA received (in %) in High income: OECD in 2007 to that in 2010?
Your answer should be compact. 0.55. What is the ratio of the ODA received (in %) of Burundi in 2007 to that in 2010?
Provide a succinct answer. 1.13. What is the ratio of the ODA received (in %) in Equatorial Guinea in 2007 to that in 2010?
Your response must be concise. 0.27. What is the ratio of the ODA received (in %) in Malaysia in 2007 to that in 2010?
Give a very brief answer. 126.59. What is the ratio of the ODA received (in %) of High income: OECD in 2007 to that in 2011?
Provide a succinct answer. 0.72. What is the ratio of the ODA received (in %) of Burundi in 2007 to that in 2011?
Offer a terse response. 1.44. What is the ratio of the ODA received (in %) in Equatorial Guinea in 2007 to that in 2011?
Make the answer very short. 1.54. What is the ratio of the ODA received (in %) of Malaysia in 2007 to that in 2011?
Provide a succinct answer. 9.57. What is the ratio of the ODA received (in %) in High income: OECD in 2007 to that in 2012?
Your answer should be very brief. 0.94. What is the ratio of the ODA received (in %) in Burundi in 2007 to that in 2012?
Ensure brevity in your answer.  1.67. What is the ratio of the ODA received (in %) in Equatorial Guinea in 2007 to that in 2012?
Your response must be concise. 2.83. What is the ratio of the ODA received (in %) of Malaysia in 2007 to that in 2012?
Give a very brief answer. 20.81. What is the ratio of the ODA received (in %) of High income: OECD in 2008 to that in 2009?
Offer a terse response. 1.29. What is the ratio of the ODA received (in %) of Equatorial Guinea in 2008 to that in 2009?
Offer a very short reply. 0.48. What is the ratio of the ODA received (in %) of Malaysia in 2008 to that in 2009?
Ensure brevity in your answer.  0.96. What is the ratio of the ODA received (in %) of High income: OECD in 2008 to that in 2010?
Provide a succinct answer. 0.54. What is the ratio of the ODA received (in %) of Burundi in 2008 to that in 2010?
Keep it short and to the point. 1.04. What is the ratio of the ODA received (in %) of Equatorial Guinea in 2008 to that in 2010?
Provide a short and direct response. 0.21. What is the ratio of the ODA received (in %) in Malaysia in 2008 to that in 2010?
Offer a very short reply. 82.71. What is the ratio of the ODA received (in %) of High income: OECD in 2008 to that in 2011?
Your response must be concise. 0.7. What is the ratio of the ODA received (in %) in Burundi in 2008 to that in 2011?
Make the answer very short. 1.32. What is the ratio of the ODA received (in %) of Equatorial Guinea in 2008 to that in 2011?
Provide a succinct answer. 1.17. What is the ratio of the ODA received (in %) in Malaysia in 2008 to that in 2011?
Provide a succinct answer. 6.25. What is the ratio of the ODA received (in %) of High income: OECD in 2008 to that in 2012?
Your response must be concise. 0.92. What is the ratio of the ODA received (in %) of Burundi in 2008 to that in 2012?
Ensure brevity in your answer.  1.53. What is the ratio of the ODA received (in %) in Equatorial Guinea in 2008 to that in 2012?
Provide a short and direct response. 2.17. What is the ratio of the ODA received (in %) of Malaysia in 2008 to that in 2012?
Ensure brevity in your answer.  13.6. What is the ratio of the ODA received (in %) of High income: OECD in 2009 to that in 2010?
Offer a very short reply. 0.42. What is the ratio of the ODA received (in %) in Burundi in 2009 to that in 2010?
Keep it short and to the point. 1.04. What is the ratio of the ODA received (in %) in Equatorial Guinea in 2009 to that in 2010?
Your answer should be very brief. 0.43. What is the ratio of the ODA received (in %) in Malaysia in 2009 to that in 2010?
Give a very brief answer. 86.44. What is the ratio of the ODA received (in %) of High income: OECD in 2009 to that in 2011?
Your response must be concise. 0.54. What is the ratio of the ODA received (in %) in Burundi in 2009 to that in 2011?
Your answer should be very brief. 1.33. What is the ratio of the ODA received (in %) of Equatorial Guinea in 2009 to that in 2011?
Your answer should be very brief. 2.45. What is the ratio of the ODA received (in %) of Malaysia in 2009 to that in 2011?
Give a very brief answer. 6.54. What is the ratio of the ODA received (in %) of High income: OECD in 2009 to that in 2012?
Your answer should be very brief. 0.71. What is the ratio of the ODA received (in %) of Burundi in 2009 to that in 2012?
Your answer should be very brief. 1.54. What is the ratio of the ODA received (in %) in Equatorial Guinea in 2009 to that in 2012?
Provide a short and direct response. 4.52. What is the ratio of the ODA received (in %) of Malaysia in 2009 to that in 2012?
Offer a very short reply. 14.21. What is the ratio of the ODA received (in %) in High income: OECD in 2010 to that in 2011?
Offer a terse response. 1.3. What is the ratio of the ODA received (in %) in Burundi in 2010 to that in 2011?
Provide a succinct answer. 1.27. What is the ratio of the ODA received (in %) of Equatorial Guinea in 2010 to that in 2011?
Provide a short and direct response. 5.66. What is the ratio of the ODA received (in %) of Malaysia in 2010 to that in 2011?
Provide a succinct answer. 0.08. What is the ratio of the ODA received (in %) in High income: OECD in 2010 to that in 2012?
Your answer should be compact. 1.7. What is the ratio of the ODA received (in %) of Burundi in 2010 to that in 2012?
Your answer should be compact. 1.47. What is the ratio of the ODA received (in %) of Equatorial Guinea in 2010 to that in 2012?
Keep it short and to the point. 10.44. What is the ratio of the ODA received (in %) in Malaysia in 2010 to that in 2012?
Make the answer very short. 0.16. What is the ratio of the ODA received (in %) in High income: OECD in 2011 to that in 2012?
Offer a terse response. 1.31. What is the ratio of the ODA received (in %) in Burundi in 2011 to that in 2012?
Keep it short and to the point. 1.16. What is the ratio of the ODA received (in %) in Equatorial Guinea in 2011 to that in 2012?
Your answer should be very brief. 1.85. What is the ratio of the ODA received (in %) in Malaysia in 2011 to that in 2012?
Your answer should be compact. 2.17. What is the difference between the highest and the second highest ODA received (in %) of Burundi?
Provide a succinct answer. 1.4. What is the difference between the highest and the second highest ODA received (in %) of Equatorial Guinea?
Make the answer very short. 0.8. What is the difference between the highest and the second highest ODA received (in %) in Malaysia?
Provide a short and direct response. 0.05. What is the difference between the highest and the lowest ODA received (in %) in Burundi?
Ensure brevity in your answer.  14.26. What is the difference between the highest and the lowest ODA received (in %) of Equatorial Guinea?
Your answer should be very brief. 1.28. What is the difference between the highest and the lowest ODA received (in %) in Malaysia?
Provide a succinct answer. 0.15. 